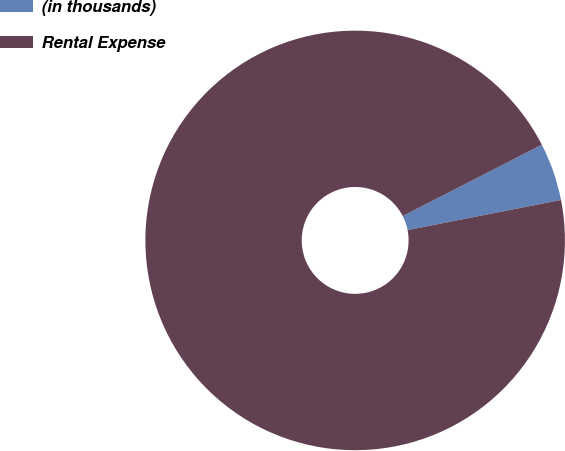Convert chart to OTSL. <chart><loc_0><loc_0><loc_500><loc_500><pie_chart><fcel>(in thousands)<fcel>Rental Expense<nl><fcel>4.45%<fcel>95.55%<nl></chart> 